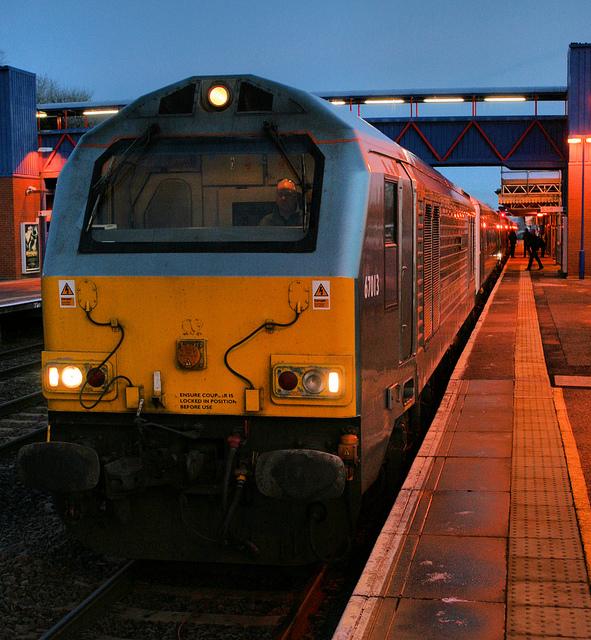What color is the train?
Keep it brief. Blue and yellow. Is the train headed toward you?
Concise answer only. Yes. Where is the train?
Short answer required. Station. What side of the train are the people sitting?
Concise answer only. Right. Are all the lights working on the train?
Write a very short answer. No. 